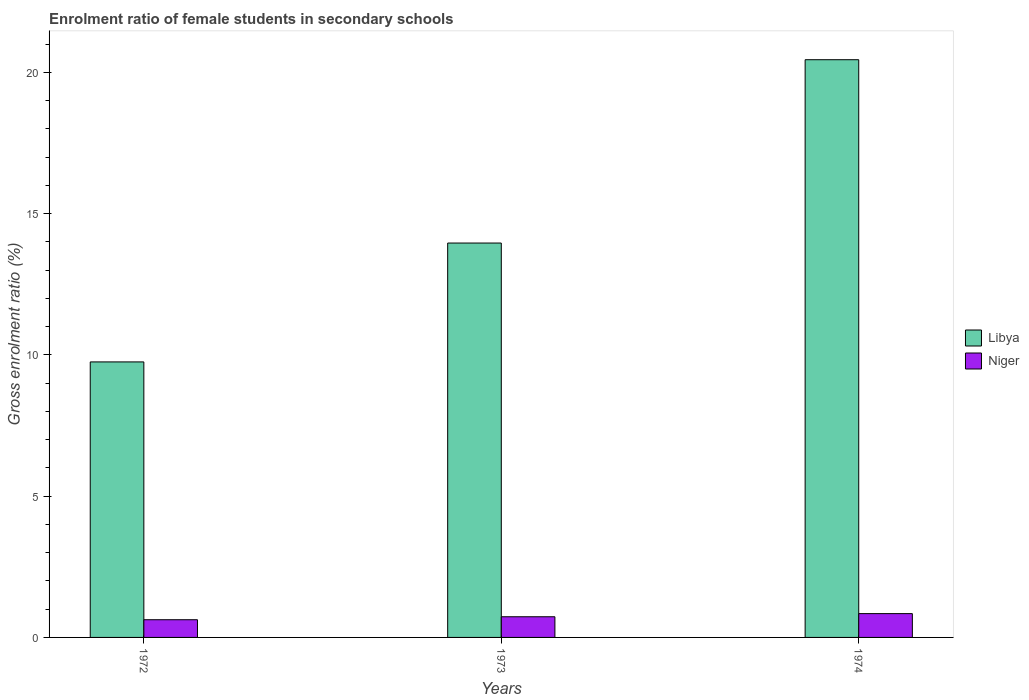How many different coloured bars are there?
Give a very brief answer. 2. How many groups of bars are there?
Make the answer very short. 3. Are the number of bars per tick equal to the number of legend labels?
Keep it short and to the point. Yes. Are the number of bars on each tick of the X-axis equal?
Offer a terse response. Yes. How many bars are there on the 1st tick from the left?
Offer a terse response. 2. How many bars are there on the 2nd tick from the right?
Ensure brevity in your answer.  2. What is the enrolment ratio of female students in secondary schools in Niger in 1972?
Offer a very short reply. 0.63. Across all years, what is the maximum enrolment ratio of female students in secondary schools in Niger?
Make the answer very short. 0.84. Across all years, what is the minimum enrolment ratio of female students in secondary schools in Niger?
Make the answer very short. 0.63. In which year was the enrolment ratio of female students in secondary schools in Niger maximum?
Offer a very short reply. 1974. In which year was the enrolment ratio of female students in secondary schools in Libya minimum?
Your answer should be compact. 1972. What is the total enrolment ratio of female students in secondary schools in Libya in the graph?
Your response must be concise. 44.16. What is the difference between the enrolment ratio of female students in secondary schools in Libya in 1972 and that in 1973?
Provide a succinct answer. -4.21. What is the difference between the enrolment ratio of female students in secondary schools in Niger in 1973 and the enrolment ratio of female students in secondary schools in Libya in 1974?
Keep it short and to the point. -19.72. What is the average enrolment ratio of female students in secondary schools in Libya per year?
Provide a short and direct response. 14.72. In the year 1973, what is the difference between the enrolment ratio of female students in secondary schools in Libya and enrolment ratio of female students in secondary schools in Niger?
Provide a short and direct response. 13.23. In how many years, is the enrolment ratio of female students in secondary schools in Niger greater than 1 %?
Your answer should be very brief. 0. What is the ratio of the enrolment ratio of female students in secondary schools in Libya in 1972 to that in 1974?
Provide a succinct answer. 0.48. Is the enrolment ratio of female students in secondary schools in Niger in 1972 less than that in 1973?
Provide a short and direct response. Yes. Is the difference between the enrolment ratio of female students in secondary schools in Libya in 1973 and 1974 greater than the difference between the enrolment ratio of female students in secondary schools in Niger in 1973 and 1974?
Your answer should be very brief. No. What is the difference between the highest and the second highest enrolment ratio of female students in secondary schools in Niger?
Keep it short and to the point. 0.11. What is the difference between the highest and the lowest enrolment ratio of female students in secondary schools in Libya?
Provide a succinct answer. 10.7. In how many years, is the enrolment ratio of female students in secondary schools in Libya greater than the average enrolment ratio of female students in secondary schools in Libya taken over all years?
Keep it short and to the point. 1. What does the 2nd bar from the left in 1972 represents?
Your answer should be very brief. Niger. What does the 1st bar from the right in 1973 represents?
Your response must be concise. Niger. How many years are there in the graph?
Offer a very short reply. 3. What is the difference between two consecutive major ticks on the Y-axis?
Offer a very short reply. 5. Does the graph contain grids?
Your answer should be very brief. No. Where does the legend appear in the graph?
Your answer should be very brief. Center right. How many legend labels are there?
Offer a very short reply. 2. What is the title of the graph?
Your answer should be compact. Enrolment ratio of female students in secondary schools. Does "Europe(developing only)" appear as one of the legend labels in the graph?
Your answer should be very brief. No. What is the Gross enrolment ratio (%) of Libya in 1972?
Offer a very short reply. 9.75. What is the Gross enrolment ratio (%) of Niger in 1972?
Keep it short and to the point. 0.63. What is the Gross enrolment ratio (%) of Libya in 1973?
Provide a short and direct response. 13.96. What is the Gross enrolment ratio (%) in Niger in 1973?
Your answer should be compact. 0.73. What is the Gross enrolment ratio (%) in Libya in 1974?
Keep it short and to the point. 20.45. What is the Gross enrolment ratio (%) of Niger in 1974?
Ensure brevity in your answer.  0.84. Across all years, what is the maximum Gross enrolment ratio (%) in Libya?
Offer a terse response. 20.45. Across all years, what is the maximum Gross enrolment ratio (%) in Niger?
Ensure brevity in your answer.  0.84. Across all years, what is the minimum Gross enrolment ratio (%) in Libya?
Ensure brevity in your answer.  9.75. Across all years, what is the minimum Gross enrolment ratio (%) of Niger?
Your answer should be very brief. 0.63. What is the total Gross enrolment ratio (%) in Libya in the graph?
Your response must be concise. 44.16. What is the total Gross enrolment ratio (%) in Niger in the graph?
Provide a succinct answer. 2.2. What is the difference between the Gross enrolment ratio (%) in Libya in 1972 and that in 1973?
Offer a very short reply. -4.21. What is the difference between the Gross enrolment ratio (%) in Niger in 1972 and that in 1973?
Offer a very short reply. -0.11. What is the difference between the Gross enrolment ratio (%) of Libya in 1972 and that in 1974?
Your answer should be compact. -10.7. What is the difference between the Gross enrolment ratio (%) in Niger in 1972 and that in 1974?
Offer a very short reply. -0.22. What is the difference between the Gross enrolment ratio (%) of Libya in 1973 and that in 1974?
Give a very brief answer. -6.49. What is the difference between the Gross enrolment ratio (%) of Niger in 1973 and that in 1974?
Ensure brevity in your answer.  -0.11. What is the difference between the Gross enrolment ratio (%) of Libya in 1972 and the Gross enrolment ratio (%) of Niger in 1973?
Offer a very short reply. 9.02. What is the difference between the Gross enrolment ratio (%) in Libya in 1972 and the Gross enrolment ratio (%) in Niger in 1974?
Give a very brief answer. 8.91. What is the difference between the Gross enrolment ratio (%) in Libya in 1973 and the Gross enrolment ratio (%) in Niger in 1974?
Offer a very short reply. 13.12. What is the average Gross enrolment ratio (%) of Libya per year?
Ensure brevity in your answer.  14.72. What is the average Gross enrolment ratio (%) in Niger per year?
Offer a terse response. 0.73. In the year 1972, what is the difference between the Gross enrolment ratio (%) of Libya and Gross enrolment ratio (%) of Niger?
Your answer should be very brief. 9.12. In the year 1973, what is the difference between the Gross enrolment ratio (%) of Libya and Gross enrolment ratio (%) of Niger?
Offer a very short reply. 13.23. In the year 1974, what is the difference between the Gross enrolment ratio (%) of Libya and Gross enrolment ratio (%) of Niger?
Your answer should be very brief. 19.6. What is the ratio of the Gross enrolment ratio (%) in Libya in 1972 to that in 1973?
Offer a terse response. 0.7. What is the ratio of the Gross enrolment ratio (%) in Niger in 1972 to that in 1973?
Keep it short and to the point. 0.86. What is the ratio of the Gross enrolment ratio (%) of Libya in 1972 to that in 1974?
Offer a terse response. 0.48. What is the ratio of the Gross enrolment ratio (%) in Niger in 1972 to that in 1974?
Offer a very short reply. 0.74. What is the ratio of the Gross enrolment ratio (%) in Libya in 1973 to that in 1974?
Make the answer very short. 0.68. What is the ratio of the Gross enrolment ratio (%) of Niger in 1973 to that in 1974?
Your answer should be compact. 0.87. What is the difference between the highest and the second highest Gross enrolment ratio (%) of Libya?
Your answer should be very brief. 6.49. What is the difference between the highest and the second highest Gross enrolment ratio (%) in Niger?
Offer a very short reply. 0.11. What is the difference between the highest and the lowest Gross enrolment ratio (%) of Libya?
Your answer should be compact. 10.7. What is the difference between the highest and the lowest Gross enrolment ratio (%) in Niger?
Make the answer very short. 0.22. 